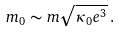Convert formula to latex. <formula><loc_0><loc_0><loc_500><loc_500>m _ { 0 } \sim m \sqrt { \kappa _ { 0 } e ^ { 3 } } \, .</formula> 